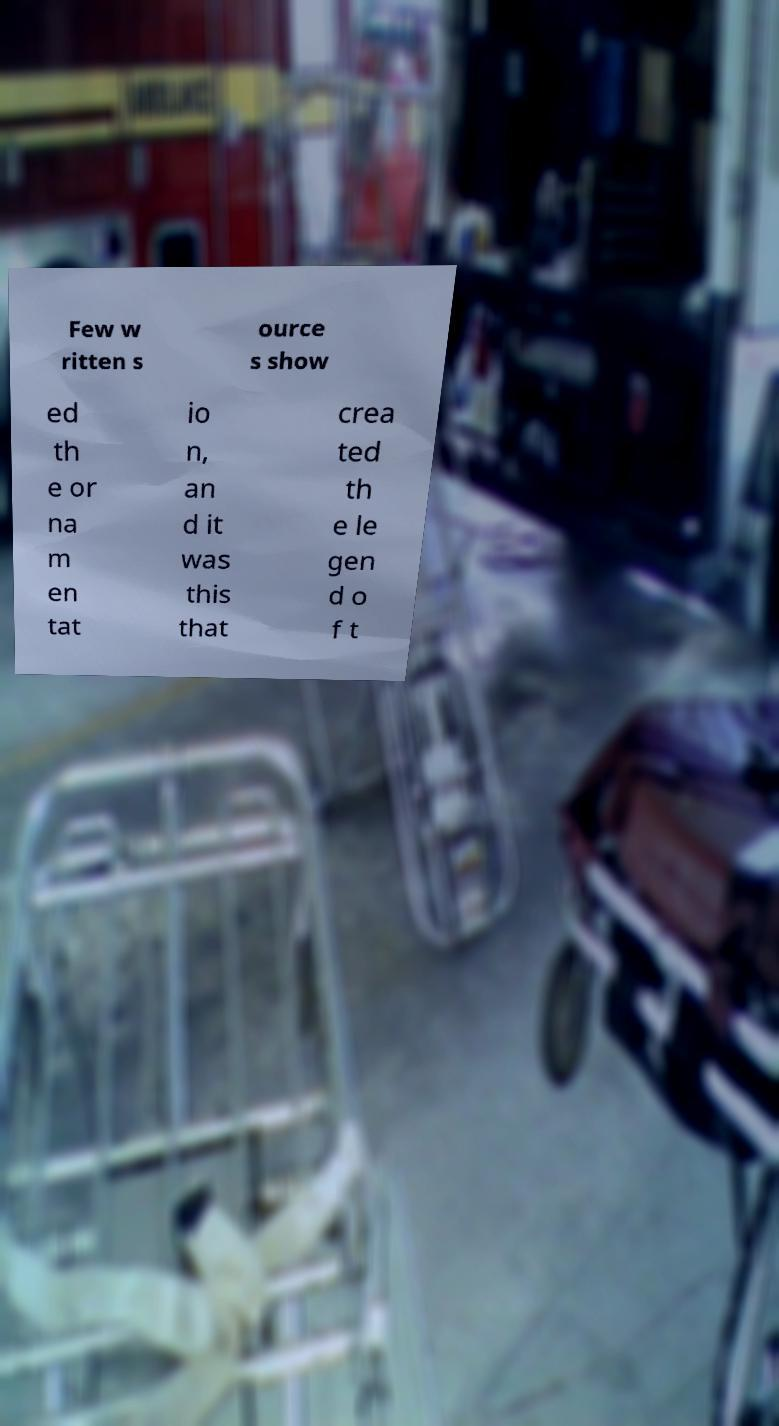Can you accurately transcribe the text from the provided image for me? Few w ritten s ource s show ed th e or na m en tat io n, an d it was this that crea ted th e le gen d o f t 